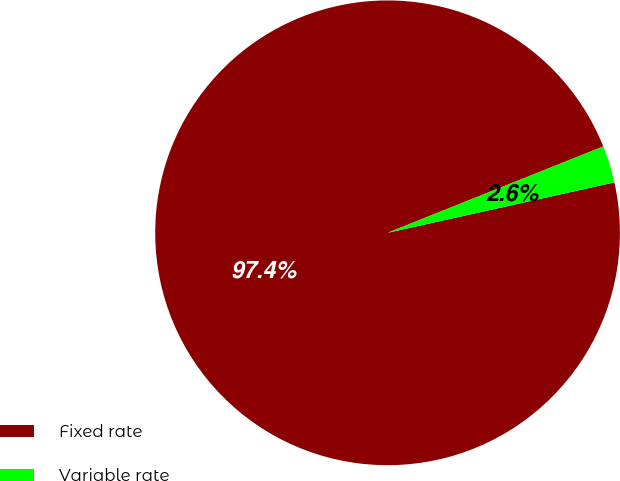<chart> <loc_0><loc_0><loc_500><loc_500><pie_chart><fcel>Fixed rate<fcel>Variable rate<nl><fcel>97.42%<fcel>2.58%<nl></chart> 